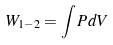Convert formula to latex. <formula><loc_0><loc_0><loc_500><loc_500>W _ { 1 - 2 } = \int P d V</formula> 